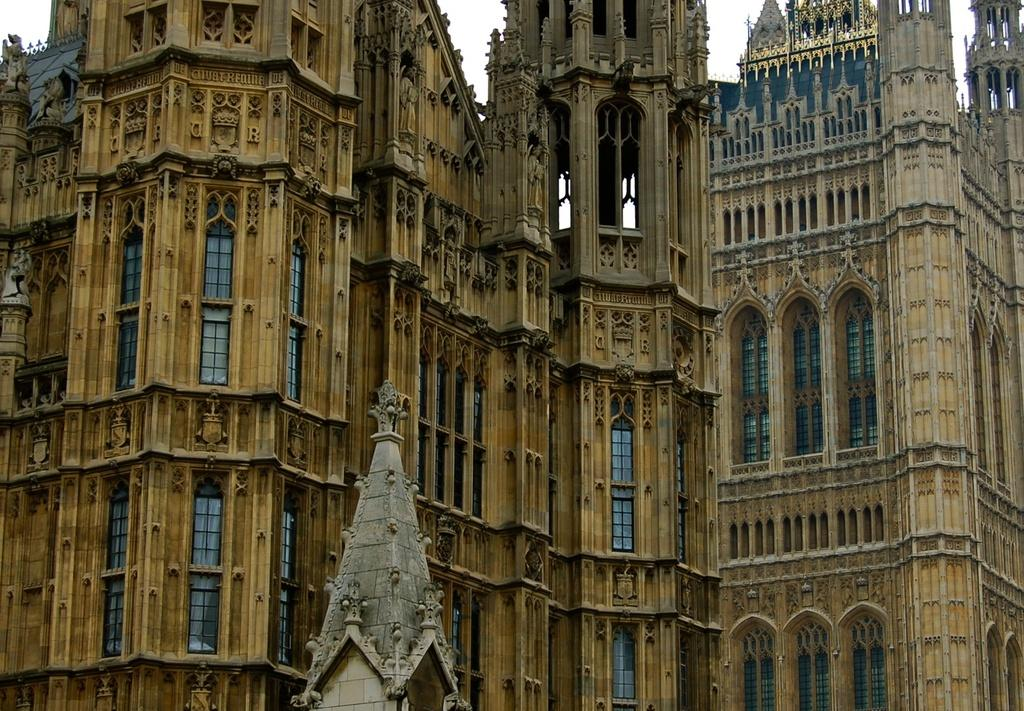What type of structures are present in the image? There are buildings in the image. What feature can be seen on the buildings? The buildings have windows. How do the buildings in the image appear? The buildings resemble a palace. How many copies of the coat can be seen in the image? There is no coat present in the image. What type of ticket is required to enter the palace in the image? There is no ticket or entrance requirement mentioned in the image, as it only shows the exterior of the buildings. 